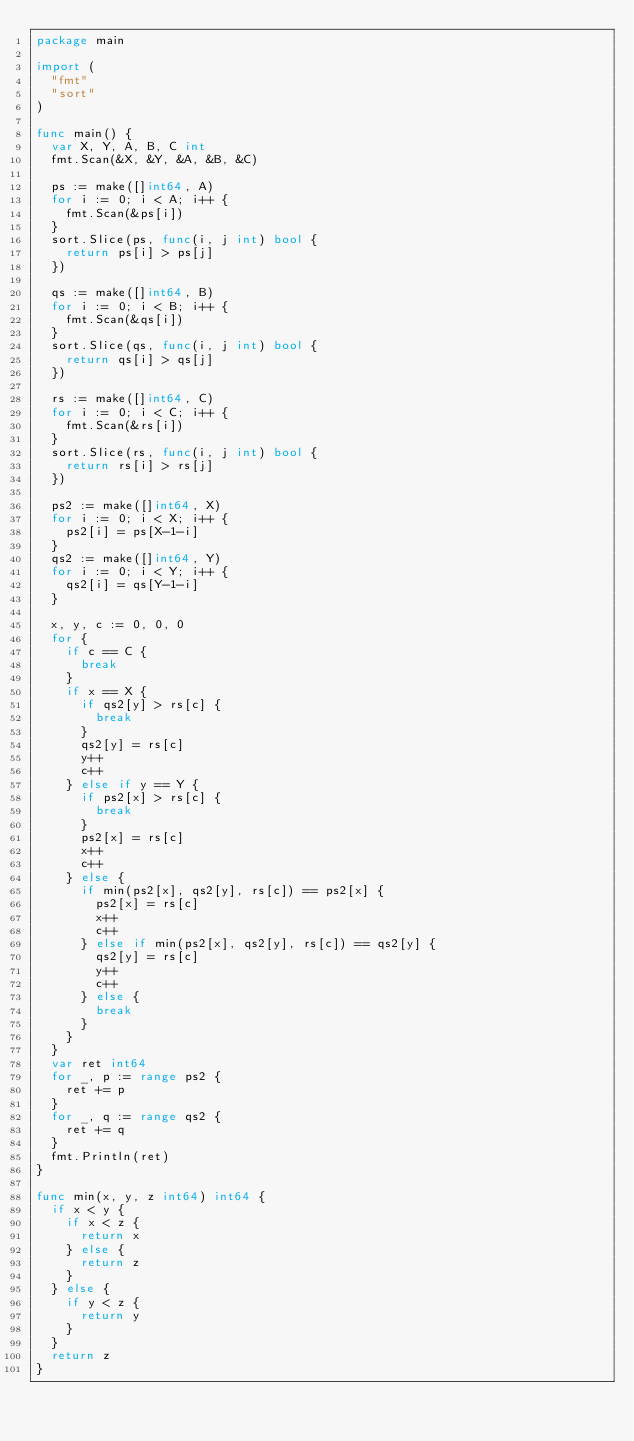Convert code to text. <code><loc_0><loc_0><loc_500><loc_500><_Go_>package main

import (
	"fmt"
	"sort"
)

func main() {
	var X, Y, A, B, C int
	fmt.Scan(&X, &Y, &A, &B, &C)

	ps := make([]int64, A)
	for i := 0; i < A; i++ {
		fmt.Scan(&ps[i])
	}
	sort.Slice(ps, func(i, j int) bool {
		return ps[i] > ps[j]
	})

	qs := make([]int64, B)
	for i := 0; i < B; i++ {
		fmt.Scan(&qs[i])
	}
	sort.Slice(qs, func(i, j int) bool {
		return qs[i] > qs[j]
	})

	rs := make([]int64, C)
	for i := 0; i < C; i++ {
		fmt.Scan(&rs[i])
	}
	sort.Slice(rs, func(i, j int) bool {
		return rs[i] > rs[j]
	})

	ps2 := make([]int64, X)
	for i := 0; i < X; i++ {
		ps2[i] = ps[X-1-i]
	}
	qs2 := make([]int64, Y)
	for i := 0; i < Y; i++ {
		qs2[i] = qs[Y-1-i]
	}

	x, y, c := 0, 0, 0
	for {
		if c == C {
			break
		}
		if x == X {
			if qs2[y] > rs[c] {
				break
			}
			qs2[y] = rs[c]
			y++
			c++
		} else if y == Y {
			if ps2[x] > rs[c] {
				break
			}
			ps2[x] = rs[c]
			x++
			c++
		} else {
			if min(ps2[x], qs2[y], rs[c]) == ps2[x] {
				ps2[x] = rs[c]
				x++
				c++
			} else if min(ps2[x], qs2[y], rs[c]) == qs2[y] {
				qs2[y] = rs[c]
				y++
				c++
			} else {
				break
			}
		}
	}
	var ret int64
	for _, p := range ps2 {
		ret += p
	}
	for _, q := range qs2 {
		ret += q
	}
	fmt.Println(ret)
}

func min(x, y, z int64) int64 {
	if x < y {
		if x < z {
			return x
		} else {
			return z
		}
	} else {
		if y < z {
			return y
		}
	}
	return z
}
</code> 